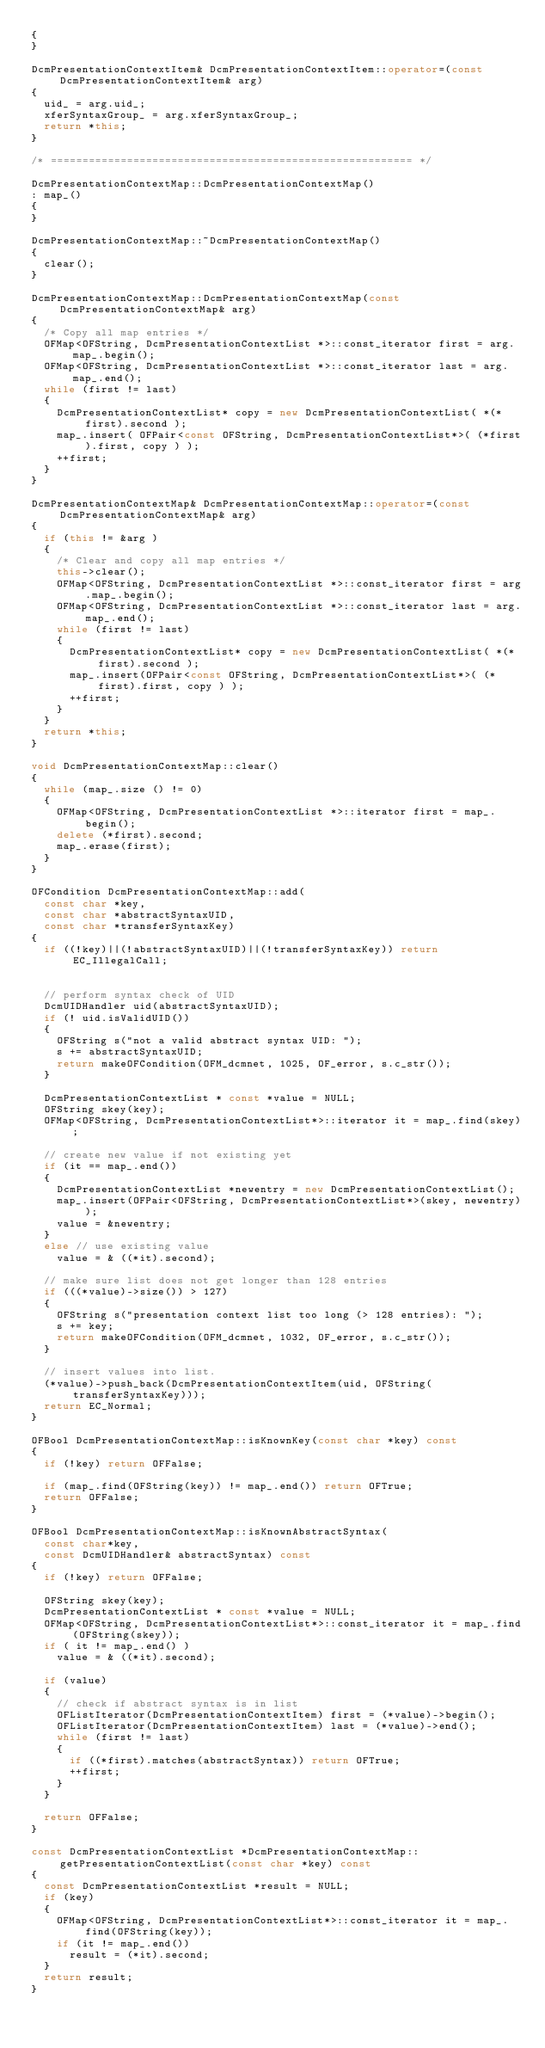Convert code to text. <code><loc_0><loc_0><loc_500><loc_500><_C++_>{
}

DcmPresentationContextItem& DcmPresentationContextItem::operator=(const DcmPresentationContextItem& arg)
{
  uid_ = arg.uid_;
  xferSyntaxGroup_ = arg.xferSyntaxGroup_;
  return *this;
}

/* ========================================================= */

DcmPresentationContextMap::DcmPresentationContextMap()
: map_()
{
}

DcmPresentationContextMap::~DcmPresentationContextMap()
{
  clear();
}

DcmPresentationContextMap::DcmPresentationContextMap(const DcmPresentationContextMap& arg)
{
  /* Copy all map entries */
  OFMap<OFString, DcmPresentationContextList *>::const_iterator first = arg.map_.begin();
  OFMap<OFString, DcmPresentationContextList *>::const_iterator last = arg.map_.end();
  while (first != last)
  {
    DcmPresentationContextList* copy = new DcmPresentationContextList( *(*first).second );
    map_.insert( OFPair<const OFString, DcmPresentationContextList*>( (*first).first, copy ) );
    ++first;
  }
}

DcmPresentationContextMap& DcmPresentationContextMap::operator=(const DcmPresentationContextMap& arg)
{
  if (this != &arg )
  {
    /* Clear and copy all map entries */
    this->clear();
    OFMap<OFString, DcmPresentationContextList *>::const_iterator first = arg.map_.begin();
    OFMap<OFString, DcmPresentationContextList *>::const_iterator last = arg.map_.end();
    while (first != last)
    {
      DcmPresentationContextList* copy = new DcmPresentationContextList( *(*first).second );
      map_.insert(OFPair<const OFString, DcmPresentationContextList*>( (*first).first, copy ) );
      ++first;
    }
  }
  return *this;
}

void DcmPresentationContextMap::clear()
{
  while (map_.size () != 0)
  {
    OFMap<OFString, DcmPresentationContextList *>::iterator first = map_.begin();
    delete (*first).second;
    map_.erase(first);
  }
}

OFCondition DcmPresentationContextMap::add(
  const char *key,
  const char *abstractSyntaxUID,
  const char *transferSyntaxKey)
{
  if ((!key)||(!abstractSyntaxUID)||(!transferSyntaxKey)) return EC_IllegalCall;


  // perform syntax check of UID
  DcmUIDHandler uid(abstractSyntaxUID);
  if (! uid.isValidUID())
  {
    OFString s("not a valid abstract syntax UID: ");
    s += abstractSyntaxUID;
    return makeOFCondition(OFM_dcmnet, 1025, OF_error, s.c_str());
  }

  DcmPresentationContextList * const *value = NULL;
  OFString skey(key);
  OFMap<OFString, DcmPresentationContextList*>::iterator it = map_.find(skey);

  // create new value if not existing yet
  if (it == map_.end())
  {
    DcmPresentationContextList *newentry = new DcmPresentationContextList();
    map_.insert(OFPair<OFString, DcmPresentationContextList*>(skey, newentry));
    value = &newentry;
  }
  else // use existing value
    value = & ((*it).second);

  // make sure list does not get longer than 128 entries
  if (((*value)->size()) > 127)
  {
    OFString s("presentation context list too long (> 128 entries): ");
    s += key;
    return makeOFCondition(OFM_dcmnet, 1032, OF_error, s.c_str());
  }

  // insert values into list.
  (*value)->push_back(DcmPresentationContextItem(uid, OFString(transferSyntaxKey)));
  return EC_Normal;
}

OFBool DcmPresentationContextMap::isKnownKey(const char *key) const
{
  if (!key) return OFFalse;

  if (map_.find(OFString(key)) != map_.end()) return OFTrue;
  return OFFalse;
}

OFBool DcmPresentationContextMap::isKnownAbstractSyntax(
  const char*key,
  const DcmUIDHandler& abstractSyntax) const
{
  if (!key) return OFFalse;

  OFString skey(key);
  DcmPresentationContextList * const *value = NULL;
  OFMap<OFString, DcmPresentationContextList*>::const_iterator it = map_.find(OFString(skey));
  if ( it != map_.end() )
    value = & ((*it).second);

  if (value)
  {
    // check if abstract syntax is in list
    OFListIterator(DcmPresentationContextItem) first = (*value)->begin();
    OFListIterator(DcmPresentationContextItem) last = (*value)->end();
    while (first != last)
    {
      if ((*first).matches(abstractSyntax)) return OFTrue;
      ++first;
    }
  }

  return OFFalse;
}

const DcmPresentationContextList *DcmPresentationContextMap::getPresentationContextList(const char *key) const
{
  const DcmPresentationContextList *result = NULL;
  if (key)
  {
    OFMap<OFString, DcmPresentationContextList*>::const_iterator it = map_.find(OFString(key));
    if (it != map_.end())
      result = (*it).second;
  }
  return result;
}
</code> 